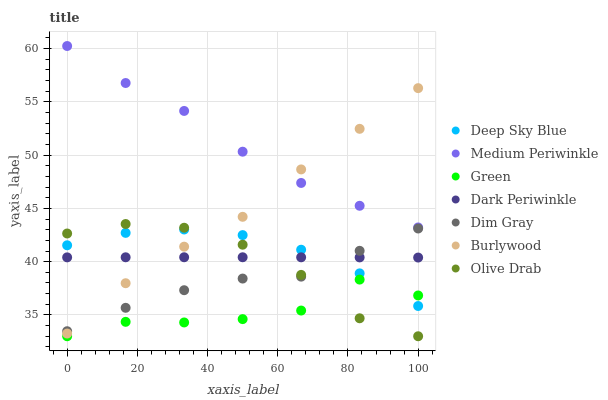Does Green have the minimum area under the curve?
Answer yes or no. Yes. Does Medium Periwinkle have the maximum area under the curve?
Answer yes or no. Yes. Does Burlywood have the minimum area under the curve?
Answer yes or no. No. Does Burlywood have the maximum area under the curve?
Answer yes or no. No. Is Dark Periwinkle the smoothest?
Answer yes or no. Yes. Is Green the roughest?
Answer yes or no. Yes. Is Burlywood the smoothest?
Answer yes or no. No. Is Burlywood the roughest?
Answer yes or no. No. Does Green have the lowest value?
Answer yes or no. Yes. Does Burlywood have the lowest value?
Answer yes or no. No. Does Medium Periwinkle have the highest value?
Answer yes or no. Yes. Does Burlywood have the highest value?
Answer yes or no. No. Is Dark Periwinkle less than Medium Periwinkle?
Answer yes or no. Yes. Is Medium Periwinkle greater than Deep Sky Blue?
Answer yes or no. Yes. Does Deep Sky Blue intersect Olive Drab?
Answer yes or no. Yes. Is Deep Sky Blue less than Olive Drab?
Answer yes or no. No. Is Deep Sky Blue greater than Olive Drab?
Answer yes or no. No. Does Dark Periwinkle intersect Medium Periwinkle?
Answer yes or no. No. 